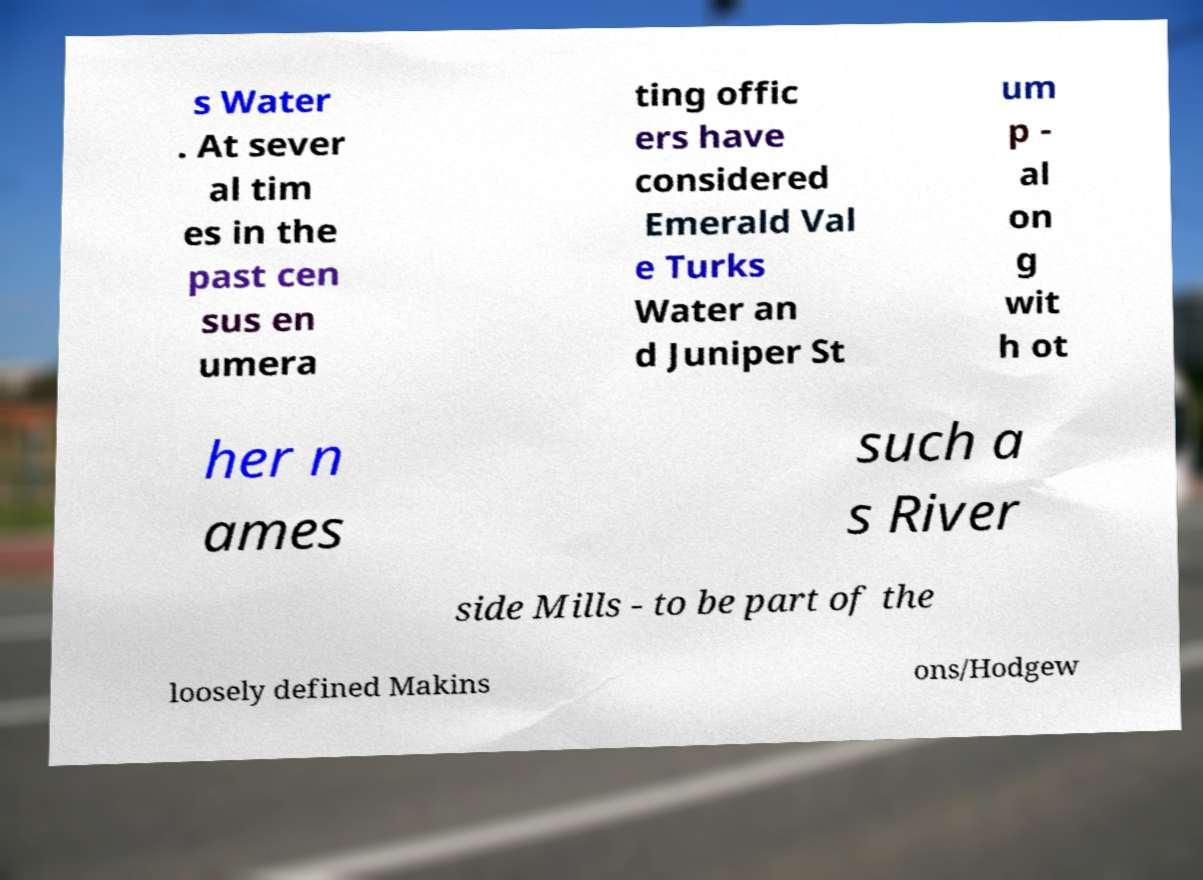For documentation purposes, I need the text within this image transcribed. Could you provide that? s Water . At sever al tim es in the past cen sus en umera ting offic ers have considered Emerald Val e Turks Water an d Juniper St um p - al on g wit h ot her n ames such a s River side Mills - to be part of the loosely defined Makins ons/Hodgew 